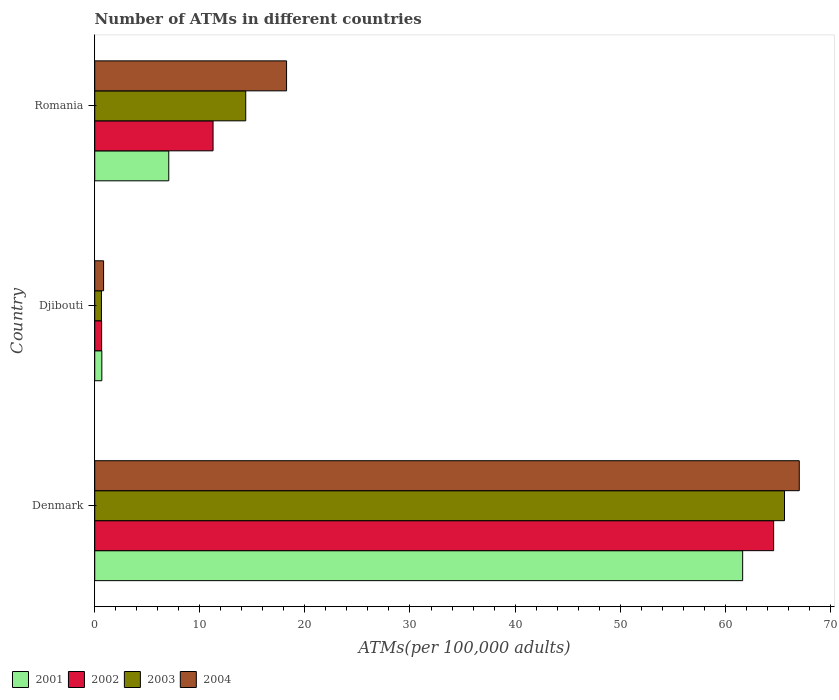Are the number of bars per tick equal to the number of legend labels?
Offer a very short reply. Yes. How many bars are there on the 2nd tick from the top?
Provide a succinct answer. 4. What is the label of the 3rd group of bars from the top?
Ensure brevity in your answer.  Denmark. In how many cases, is the number of bars for a given country not equal to the number of legend labels?
Offer a terse response. 0. What is the number of ATMs in 2004 in Djibouti?
Offer a very short reply. 0.84. Across all countries, what is the maximum number of ATMs in 2001?
Offer a terse response. 61.66. Across all countries, what is the minimum number of ATMs in 2003?
Ensure brevity in your answer.  0.64. In which country was the number of ATMs in 2003 maximum?
Your answer should be compact. Denmark. In which country was the number of ATMs in 2003 minimum?
Your response must be concise. Djibouti. What is the total number of ATMs in 2003 in the graph?
Your answer should be very brief. 80.65. What is the difference between the number of ATMs in 2004 in Denmark and that in Djibouti?
Ensure brevity in your answer.  66.2. What is the difference between the number of ATMs in 2003 in Romania and the number of ATMs in 2004 in Denmark?
Provide a short and direct response. -52.67. What is the average number of ATMs in 2002 per country?
Your answer should be compact. 25.51. What is the difference between the number of ATMs in 2003 and number of ATMs in 2001 in Denmark?
Keep it short and to the point. 3.98. In how many countries, is the number of ATMs in 2004 greater than 12 ?
Offer a very short reply. 2. What is the ratio of the number of ATMs in 2004 in Djibouti to that in Romania?
Ensure brevity in your answer.  0.05. Is the number of ATMs in 2003 in Denmark less than that in Djibouti?
Keep it short and to the point. No. What is the difference between the highest and the second highest number of ATMs in 2001?
Your answer should be very brief. 54.61. What is the difference between the highest and the lowest number of ATMs in 2003?
Offer a very short reply. 65. In how many countries, is the number of ATMs in 2003 greater than the average number of ATMs in 2003 taken over all countries?
Offer a very short reply. 1. What does the 3rd bar from the top in Denmark represents?
Give a very brief answer. 2002. Is it the case that in every country, the sum of the number of ATMs in 2003 and number of ATMs in 2004 is greater than the number of ATMs in 2001?
Your answer should be compact. Yes. Are all the bars in the graph horizontal?
Ensure brevity in your answer.  Yes. How many countries are there in the graph?
Make the answer very short. 3. What is the difference between two consecutive major ticks on the X-axis?
Provide a short and direct response. 10. Where does the legend appear in the graph?
Provide a short and direct response. Bottom left. How many legend labels are there?
Offer a very short reply. 4. How are the legend labels stacked?
Your response must be concise. Horizontal. What is the title of the graph?
Offer a terse response. Number of ATMs in different countries. What is the label or title of the X-axis?
Make the answer very short. ATMs(per 100,0 adults). What is the ATMs(per 100,000 adults) in 2001 in Denmark?
Your answer should be compact. 61.66. What is the ATMs(per 100,000 adults) of 2002 in Denmark?
Make the answer very short. 64.61. What is the ATMs(per 100,000 adults) of 2003 in Denmark?
Ensure brevity in your answer.  65.64. What is the ATMs(per 100,000 adults) of 2004 in Denmark?
Your response must be concise. 67.04. What is the ATMs(per 100,000 adults) in 2001 in Djibouti?
Give a very brief answer. 0.68. What is the ATMs(per 100,000 adults) in 2002 in Djibouti?
Your answer should be compact. 0.66. What is the ATMs(per 100,000 adults) of 2003 in Djibouti?
Provide a short and direct response. 0.64. What is the ATMs(per 100,000 adults) of 2004 in Djibouti?
Ensure brevity in your answer.  0.84. What is the ATMs(per 100,000 adults) of 2001 in Romania?
Keep it short and to the point. 7.04. What is the ATMs(per 100,000 adults) of 2002 in Romania?
Your response must be concise. 11.26. What is the ATMs(per 100,000 adults) of 2003 in Romania?
Offer a terse response. 14.37. What is the ATMs(per 100,000 adults) of 2004 in Romania?
Your response must be concise. 18.26. Across all countries, what is the maximum ATMs(per 100,000 adults) of 2001?
Keep it short and to the point. 61.66. Across all countries, what is the maximum ATMs(per 100,000 adults) of 2002?
Keep it short and to the point. 64.61. Across all countries, what is the maximum ATMs(per 100,000 adults) in 2003?
Give a very brief answer. 65.64. Across all countries, what is the maximum ATMs(per 100,000 adults) of 2004?
Provide a succinct answer. 67.04. Across all countries, what is the minimum ATMs(per 100,000 adults) of 2001?
Make the answer very short. 0.68. Across all countries, what is the minimum ATMs(per 100,000 adults) in 2002?
Offer a terse response. 0.66. Across all countries, what is the minimum ATMs(per 100,000 adults) of 2003?
Your response must be concise. 0.64. Across all countries, what is the minimum ATMs(per 100,000 adults) in 2004?
Your answer should be compact. 0.84. What is the total ATMs(per 100,000 adults) of 2001 in the graph?
Provide a short and direct response. 69.38. What is the total ATMs(per 100,000 adults) of 2002 in the graph?
Offer a very short reply. 76.52. What is the total ATMs(per 100,000 adults) in 2003 in the graph?
Your response must be concise. 80.65. What is the total ATMs(per 100,000 adults) of 2004 in the graph?
Provide a succinct answer. 86.14. What is the difference between the ATMs(per 100,000 adults) of 2001 in Denmark and that in Djibouti?
Provide a succinct answer. 60.98. What is the difference between the ATMs(per 100,000 adults) in 2002 in Denmark and that in Djibouti?
Your response must be concise. 63.95. What is the difference between the ATMs(per 100,000 adults) in 2003 in Denmark and that in Djibouti?
Your answer should be very brief. 65. What is the difference between the ATMs(per 100,000 adults) in 2004 in Denmark and that in Djibouti?
Ensure brevity in your answer.  66.2. What is the difference between the ATMs(per 100,000 adults) of 2001 in Denmark and that in Romania?
Ensure brevity in your answer.  54.61. What is the difference between the ATMs(per 100,000 adults) in 2002 in Denmark and that in Romania?
Offer a very short reply. 53.35. What is the difference between the ATMs(per 100,000 adults) in 2003 in Denmark and that in Romania?
Make the answer very short. 51.27. What is the difference between the ATMs(per 100,000 adults) in 2004 in Denmark and that in Romania?
Your answer should be very brief. 48.79. What is the difference between the ATMs(per 100,000 adults) in 2001 in Djibouti and that in Romania?
Ensure brevity in your answer.  -6.37. What is the difference between the ATMs(per 100,000 adults) in 2002 in Djibouti and that in Romania?
Give a very brief answer. -10.6. What is the difference between the ATMs(per 100,000 adults) in 2003 in Djibouti and that in Romania?
Make the answer very short. -13.73. What is the difference between the ATMs(per 100,000 adults) of 2004 in Djibouti and that in Romania?
Your answer should be compact. -17.41. What is the difference between the ATMs(per 100,000 adults) in 2001 in Denmark and the ATMs(per 100,000 adults) in 2002 in Djibouti?
Give a very brief answer. 61. What is the difference between the ATMs(per 100,000 adults) in 2001 in Denmark and the ATMs(per 100,000 adults) in 2003 in Djibouti?
Your response must be concise. 61.02. What is the difference between the ATMs(per 100,000 adults) of 2001 in Denmark and the ATMs(per 100,000 adults) of 2004 in Djibouti?
Make the answer very short. 60.81. What is the difference between the ATMs(per 100,000 adults) in 2002 in Denmark and the ATMs(per 100,000 adults) in 2003 in Djibouti?
Provide a succinct answer. 63.97. What is the difference between the ATMs(per 100,000 adults) in 2002 in Denmark and the ATMs(per 100,000 adults) in 2004 in Djibouti?
Offer a very short reply. 63.76. What is the difference between the ATMs(per 100,000 adults) of 2003 in Denmark and the ATMs(per 100,000 adults) of 2004 in Djibouti?
Offer a terse response. 64.79. What is the difference between the ATMs(per 100,000 adults) in 2001 in Denmark and the ATMs(per 100,000 adults) in 2002 in Romania?
Your response must be concise. 50.4. What is the difference between the ATMs(per 100,000 adults) in 2001 in Denmark and the ATMs(per 100,000 adults) in 2003 in Romania?
Make the answer very short. 47.29. What is the difference between the ATMs(per 100,000 adults) of 2001 in Denmark and the ATMs(per 100,000 adults) of 2004 in Romania?
Your response must be concise. 43.4. What is the difference between the ATMs(per 100,000 adults) of 2002 in Denmark and the ATMs(per 100,000 adults) of 2003 in Romania?
Your response must be concise. 50.24. What is the difference between the ATMs(per 100,000 adults) of 2002 in Denmark and the ATMs(per 100,000 adults) of 2004 in Romania?
Provide a short and direct response. 46.35. What is the difference between the ATMs(per 100,000 adults) in 2003 in Denmark and the ATMs(per 100,000 adults) in 2004 in Romania?
Ensure brevity in your answer.  47.38. What is the difference between the ATMs(per 100,000 adults) of 2001 in Djibouti and the ATMs(per 100,000 adults) of 2002 in Romania?
Offer a very short reply. -10.58. What is the difference between the ATMs(per 100,000 adults) of 2001 in Djibouti and the ATMs(per 100,000 adults) of 2003 in Romania?
Your answer should be very brief. -13.69. What is the difference between the ATMs(per 100,000 adults) of 2001 in Djibouti and the ATMs(per 100,000 adults) of 2004 in Romania?
Give a very brief answer. -17.58. What is the difference between the ATMs(per 100,000 adults) of 2002 in Djibouti and the ATMs(per 100,000 adults) of 2003 in Romania?
Your answer should be compact. -13.71. What is the difference between the ATMs(per 100,000 adults) of 2002 in Djibouti and the ATMs(per 100,000 adults) of 2004 in Romania?
Your answer should be very brief. -17.6. What is the difference between the ATMs(per 100,000 adults) of 2003 in Djibouti and the ATMs(per 100,000 adults) of 2004 in Romania?
Make the answer very short. -17.62. What is the average ATMs(per 100,000 adults) of 2001 per country?
Ensure brevity in your answer.  23.13. What is the average ATMs(per 100,000 adults) in 2002 per country?
Keep it short and to the point. 25.51. What is the average ATMs(per 100,000 adults) of 2003 per country?
Ensure brevity in your answer.  26.88. What is the average ATMs(per 100,000 adults) in 2004 per country?
Provide a succinct answer. 28.71. What is the difference between the ATMs(per 100,000 adults) of 2001 and ATMs(per 100,000 adults) of 2002 in Denmark?
Keep it short and to the point. -2.95. What is the difference between the ATMs(per 100,000 adults) of 2001 and ATMs(per 100,000 adults) of 2003 in Denmark?
Provide a short and direct response. -3.98. What is the difference between the ATMs(per 100,000 adults) of 2001 and ATMs(per 100,000 adults) of 2004 in Denmark?
Your answer should be very brief. -5.39. What is the difference between the ATMs(per 100,000 adults) in 2002 and ATMs(per 100,000 adults) in 2003 in Denmark?
Provide a succinct answer. -1.03. What is the difference between the ATMs(per 100,000 adults) of 2002 and ATMs(per 100,000 adults) of 2004 in Denmark?
Provide a succinct answer. -2.44. What is the difference between the ATMs(per 100,000 adults) in 2003 and ATMs(per 100,000 adults) in 2004 in Denmark?
Your answer should be compact. -1.41. What is the difference between the ATMs(per 100,000 adults) of 2001 and ATMs(per 100,000 adults) of 2002 in Djibouti?
Make the answer very short. 0.02. What is the difference between the ATMs(per 100,000 adults) in 2001 and ATMs(per 100,000 adults) in 2003 in Djibouti?
Offer a very short reply. 0.04. What is the difference between the ATMs(per 100,000 adults) in 2001 and ATMs(per 100,000 adults) in 2004 in Djibouti?
Offer a terse response. -0.17. What is the difference between the ATMs(per 100,000 adults) of 2002 and ATMs(per 100,000 adults) of 2003 in Djibouti?
Keep it short and to the point. 0.02. What is the difference between the ATMs(per 100,000 adults) in 2002 and ATMs(per 100,000 adults) in 2004 in Djibouti?
Offer a very short reply. -0.19. What is the difference between the ATMs(per 100,000 adults) of 2003 and ATMs(per 100,000 adults) of 2004 in Djibouti?
Keep it short and to the point. -0.21. What is the difference between the ATMs(per 100,000 adults) in 2001 and ATMs(per 100,000 adults) in 2002 in Romania?
Your answer should be very brief. -4.21. What is the difference between the ATMs(per 100,000 adults) of 2001 and ATMs(per 100,000 adults) of 2003 in Romania?
Give a very brief answer. -7.32. What is the difference between the ATMs(per 100,000 adults) of 2001 and ATMs(per 100,000 adults) of 2004 in Romania?
Provide a succinct answer. -11.21. What is the difference between the ATMs(per 100,000 adults) of 2002 and ATMs(per 100,000 adults) of 2003 in Romania?
Give a very brief answer. -3.11. What is the difference between the ATMs(per 100,000 adults) of 2002 and ATMs(per 100,000 adults) of 2004 in Romania?
Offer a very short reply. -7. What is the difference between the ATMs(per 100,000 adults) of 2003 and ATMs(per 100,000 adults) of 2004 in Romania?
Give a very brief answer. -3.89. What is the ratio of the ATMs(per 100,000 adults) in 2001 in Denmark to that in Djibouti?
Your answer should be very brief. 91.18. What is the ratio of the ATMs(per 100,000 adults) in 2002 in Denmark to that in Djibouti?
Offer a terse response. 98.45. What is the ratio of the ATMs(per 100,000 adults) in 2003 in Denmark to that in Djibouti?
Give a very brief answer. 102.88. What is the ratio of the ATMs(per 100,000 adults) of 2004 in Denmark to that in Djibouti?
Keep it short and to the point. 79.46. What is the ratio of the ATMs(per 100,000 adults) of 2001 in Denmark to that in Romania?
Provide a succinct answer. 8.75. What is the ratio of the ATMs(per 100,000 adults) in 2002 in Denmark to that in Romania?
Make the answer very short. 5.74. What is the ratio of the ATMs(per 100,000 adults) of 2003 in Denmark to that in Romania?
Keep it short and to the point. 4.57. What is the ratio of the ATMs(per 100,000 adults) of 2004 in Denmark to that in Romania?
Offer a very short reply. 3.67. What is the ratio of the ATMs(per 100,000 adults) of 2001 in Djibouti to that in Romania?
Your response must be concise. 0.1. What is the ratio of the ATMs(per 100,000 adults) in 2002 in Djibouti to that in Romania?
Keep it short and to the point. 0.06. What is the ratio of the ATMs(per 100,000 adults) in 2003 in Djibouti to that in Romania?
Provide a succinct answer. 0.04. What is the ratio of the ATMs(per 100,000 adults) in 2004 in Djibouti to that in Romania?
Keep it short and to the point. 0.05. What is the difference between the highest and the second highest ATMs(per 100,000 adults) of 2001?
Make the answer very short. 54.61. What is the difference between the highest and the second highest ATMs(per 100,000 adults) in 2002?
Offer a terse response. 53.35. What is the difference between the highest and the second highest ATMs(per 100,000 adults) in 2003?
Ensure brevity in your answer.  51.27. What is the difference between the highest and the second highest ATMs(per 100,000 adults) in 2004?
Your answer should be compact. 48.79. What is the difference between the highest and the lowest ATMs(per 100,000 adults) of 2001?
Offer a terse response. 60.98. What is the difference between the highest and the lowest ATMs(per 100,000 adults) in 2002?
Offer a terse response. 63.95. What is the difference between the highest and the lowest ATMs(per 100,000 adults) of 2003?
Give a very brief answer. 65. What is the difference between the highest and the lowest ATMs(per 100,000 adults) of 2004?
Keep it short and to the point. 66.2. 